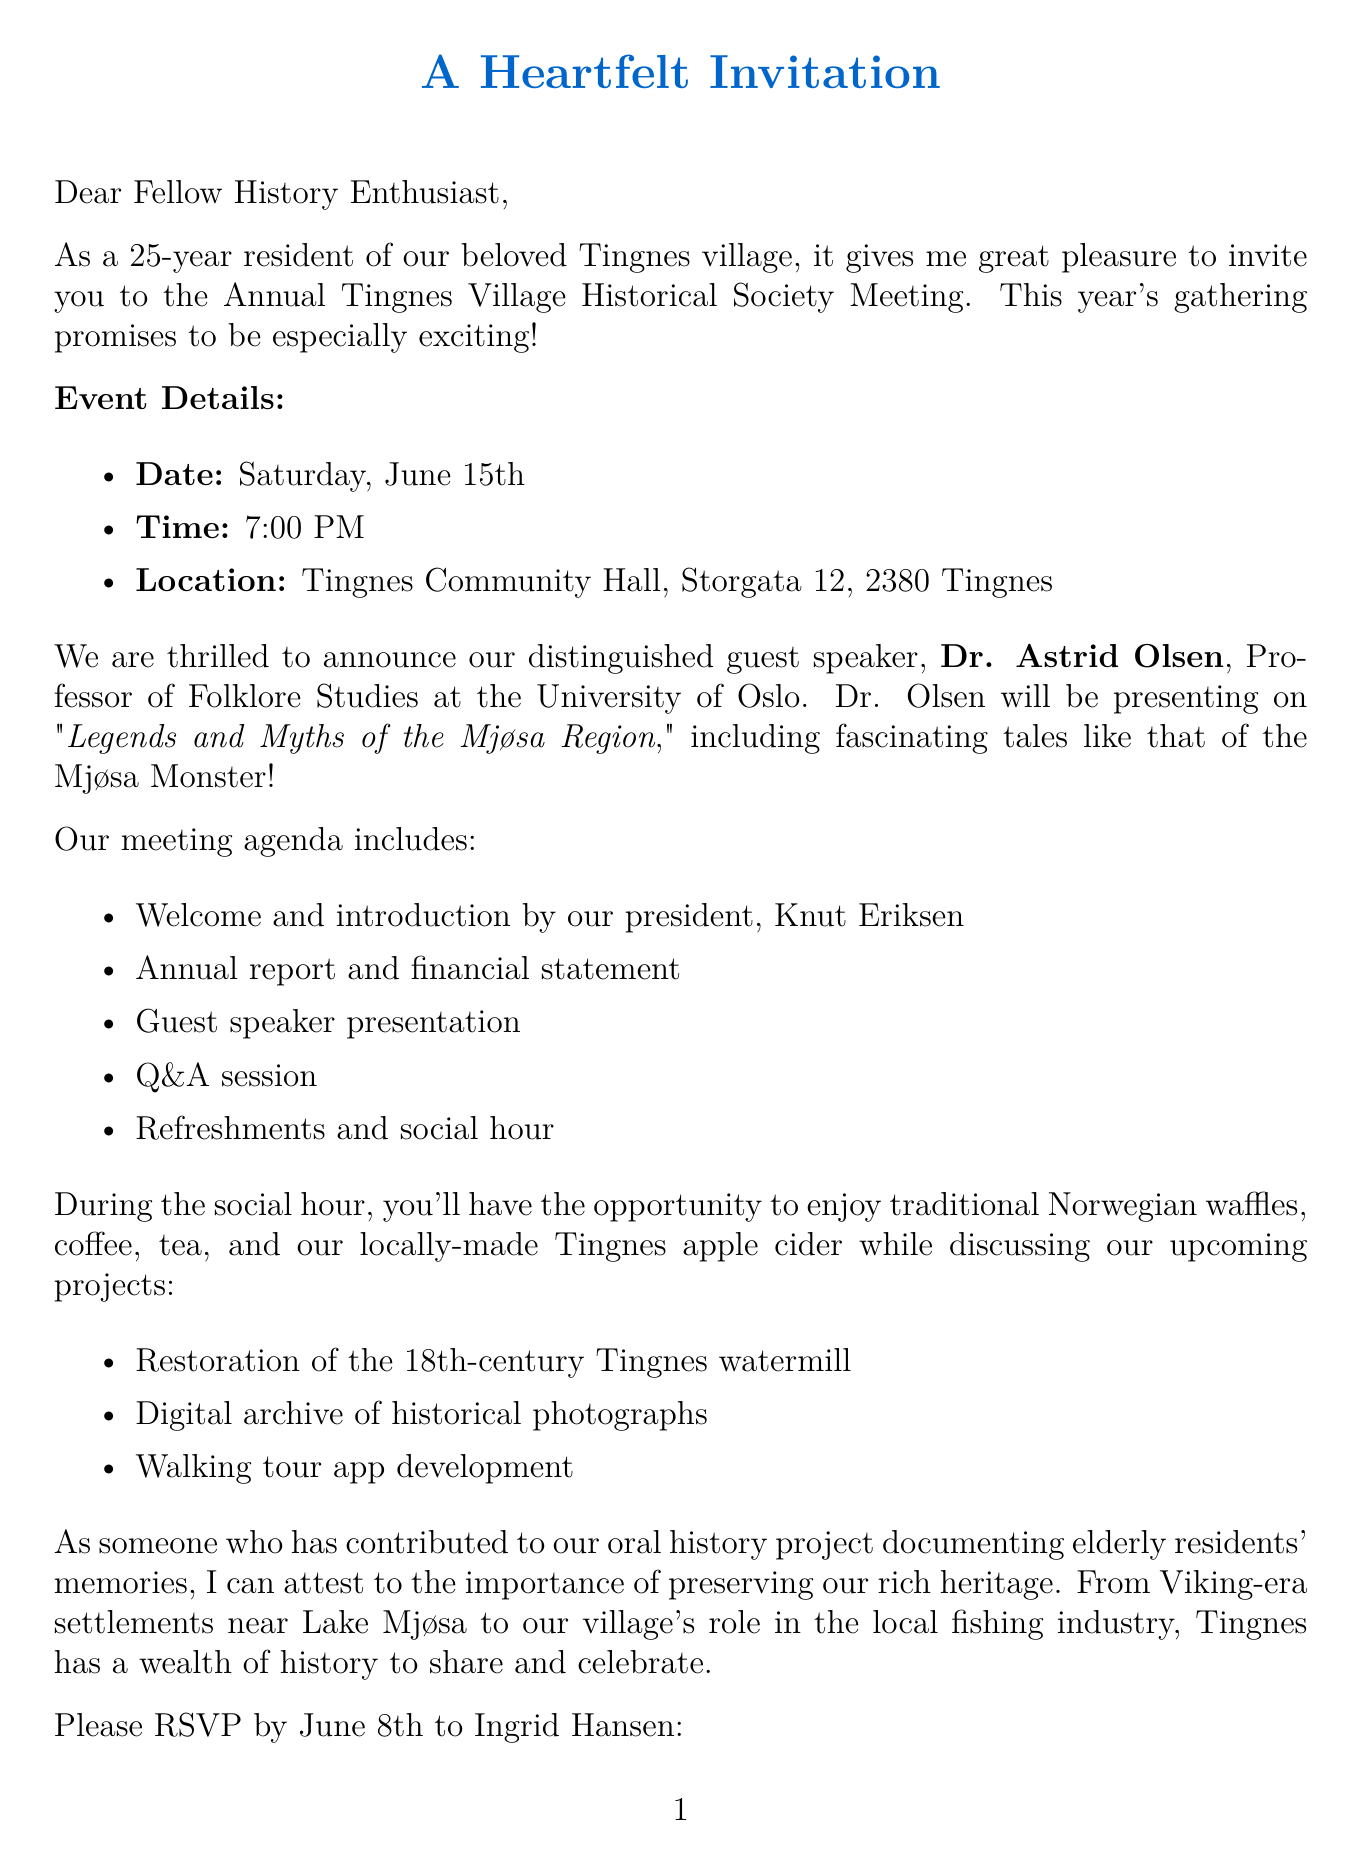What is the date of the meeting? The date of the meeting is specifically mentioned as Saturday, June 15th in the event details.
Answer: Saturday, June 15th Who is the guest speaker? The guest speaker is named in the document, along with their title and affiliation.
Answer: Dr. Astrid Olsen What is the location of the event? The location is clearly stated in the event details section of the letter.
Answer: Tingnes Community Hall What is the favorite historical site of the resident? This personal detail about the resident’s connection to Tingnes is provided in the personal connection section.
Answer: Old Tingnes Church What project involves the restoration of a historic site? The upcoming projects section specifies a project focused on restoring a specific historic site in the village.
Answer: Restoration of the 18th-century Tingnes watermill What will be served during the social hour? The document lists refreshments offered during the social hour, which can be found in the meeting agenda section.
Answer: Traditional Norwegian waffles, coffee, tea, and Tingnes apple cider Who is the president of the Tingnes Village Historical Society? The president’s name is provided in the historical society information section.
Answer: Knut Eriksen When is the RSVP deadline? The RSVP details state a specific deadline for responses.
Answer: June 8th 